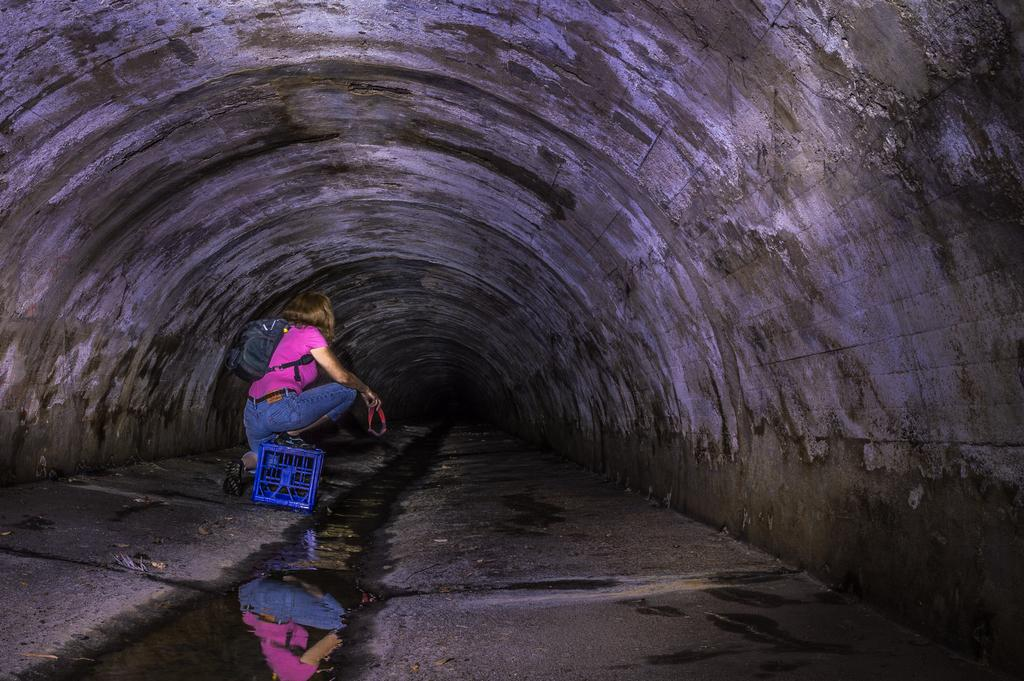Who is present in the image? There is a woman in the image. What is the woman wearing? The woman is wearing a pink T-shirt and blue jeans. Does the woman have any accessories or belongings? Yes, the woman has a bag. What is located behind the woman? There is a box behind the woman. Where is the woman sitting? The woman is sitting in a tunnel. What type of corn is being discussed by the woman in the image? There is no corn or discussion present in the image. Can you see any flies in the image? There are no flies visible in the image. 